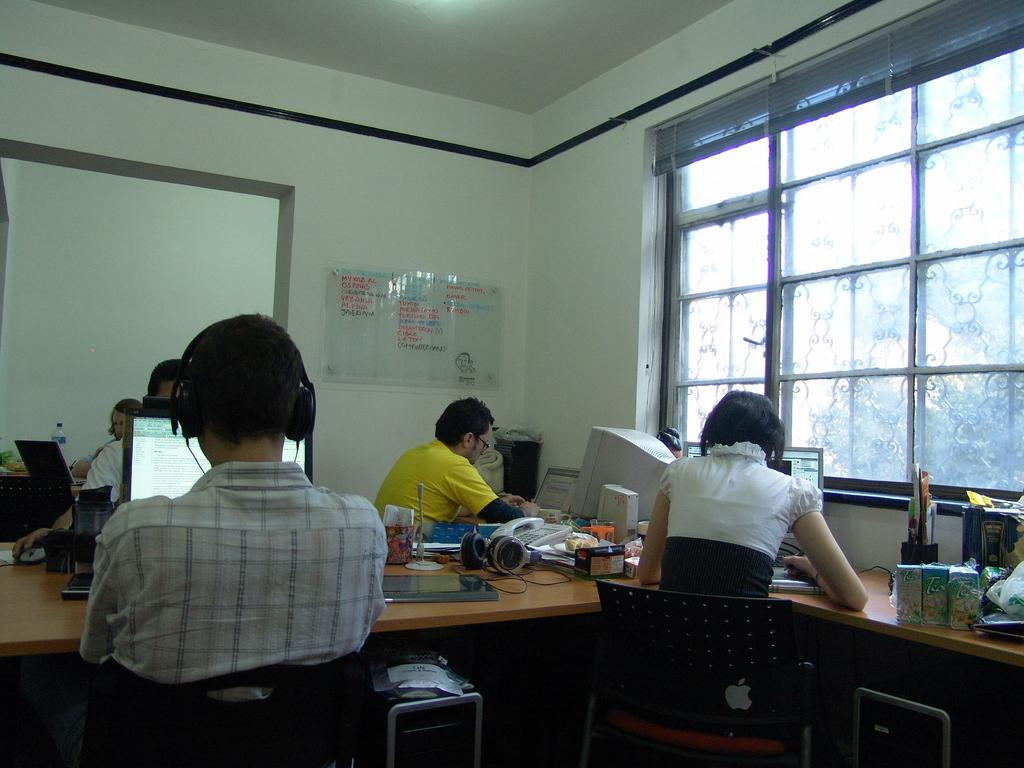What are the people in the image doing? The people in the image are sitting on chairs. What electronic devices can be seen in the image? There are laptops and computers visible in the image. What else can be found on the tables in the image? There are additional items or "stuffs" on the tables in the image. What type of flame can be seen coming from the pail in the image? There is no pail or flame present in the image; there are only people, chairs, laptops, computers, and additional items on the tables. 